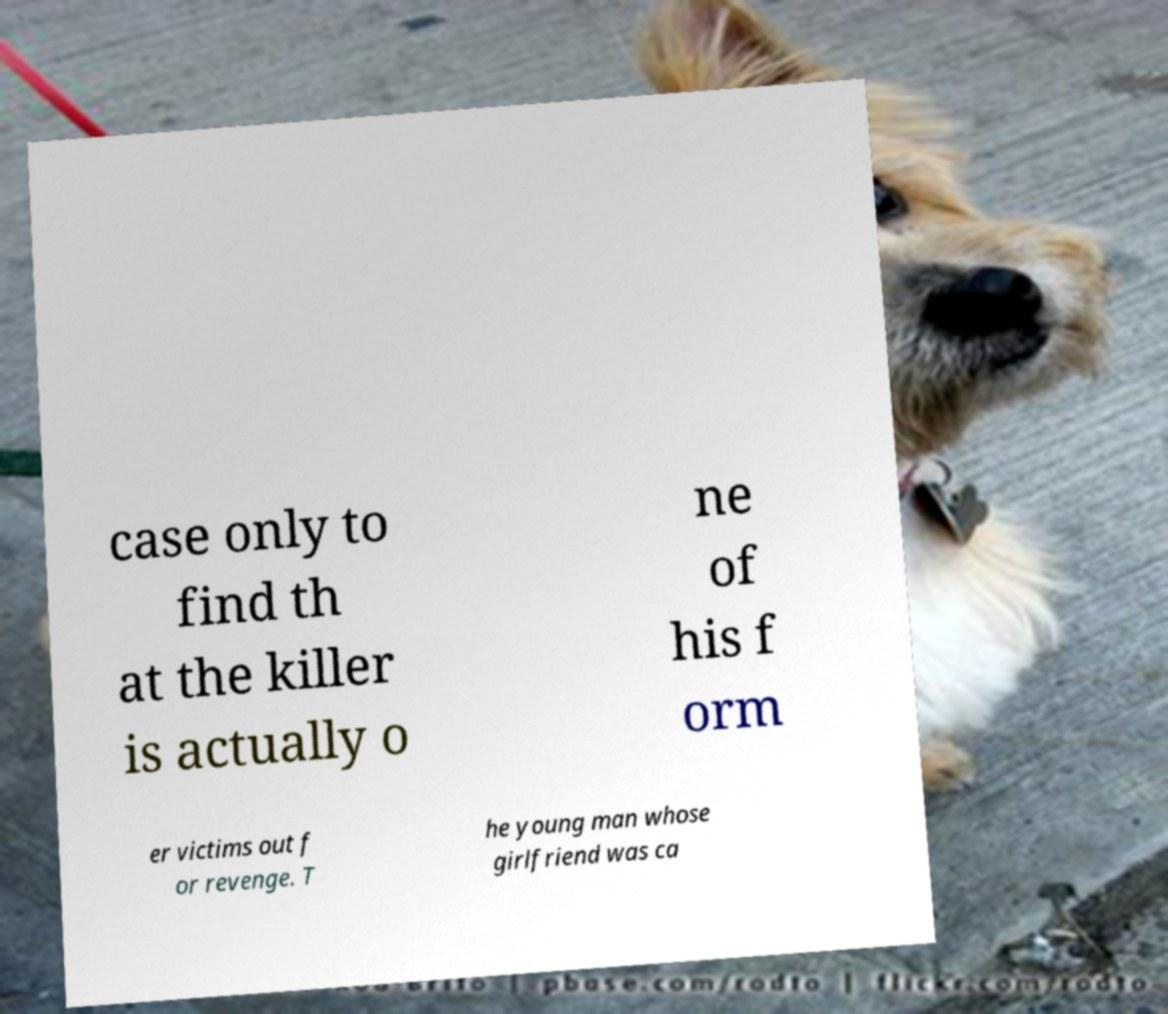Could you assist in decoding the text presented in this image and type it out clearly? case only to find th at the killer is actually o ne of his f orm er victims out f or revenge. T he young man whose girlfriend was ca 